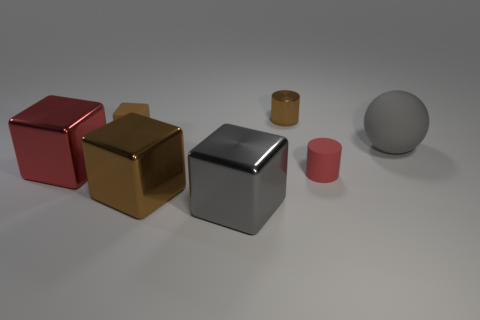Subtract 1 cubes. How many cubes are left? 3 Add 1 tiny brown cylinders. How many objects exist? 8 Subtract all spheres. How many objects are left? 6 Subtract all tiny matte cylinders. Subtract all gray metallic cubes. How many objects are left? 5 Add 5 red objects. How many red objects are left? 7 Add 6 metal cylinders. How many metal cylinders exist? 7 Subtract 1 brown cylinders. How many objects are left? 6 